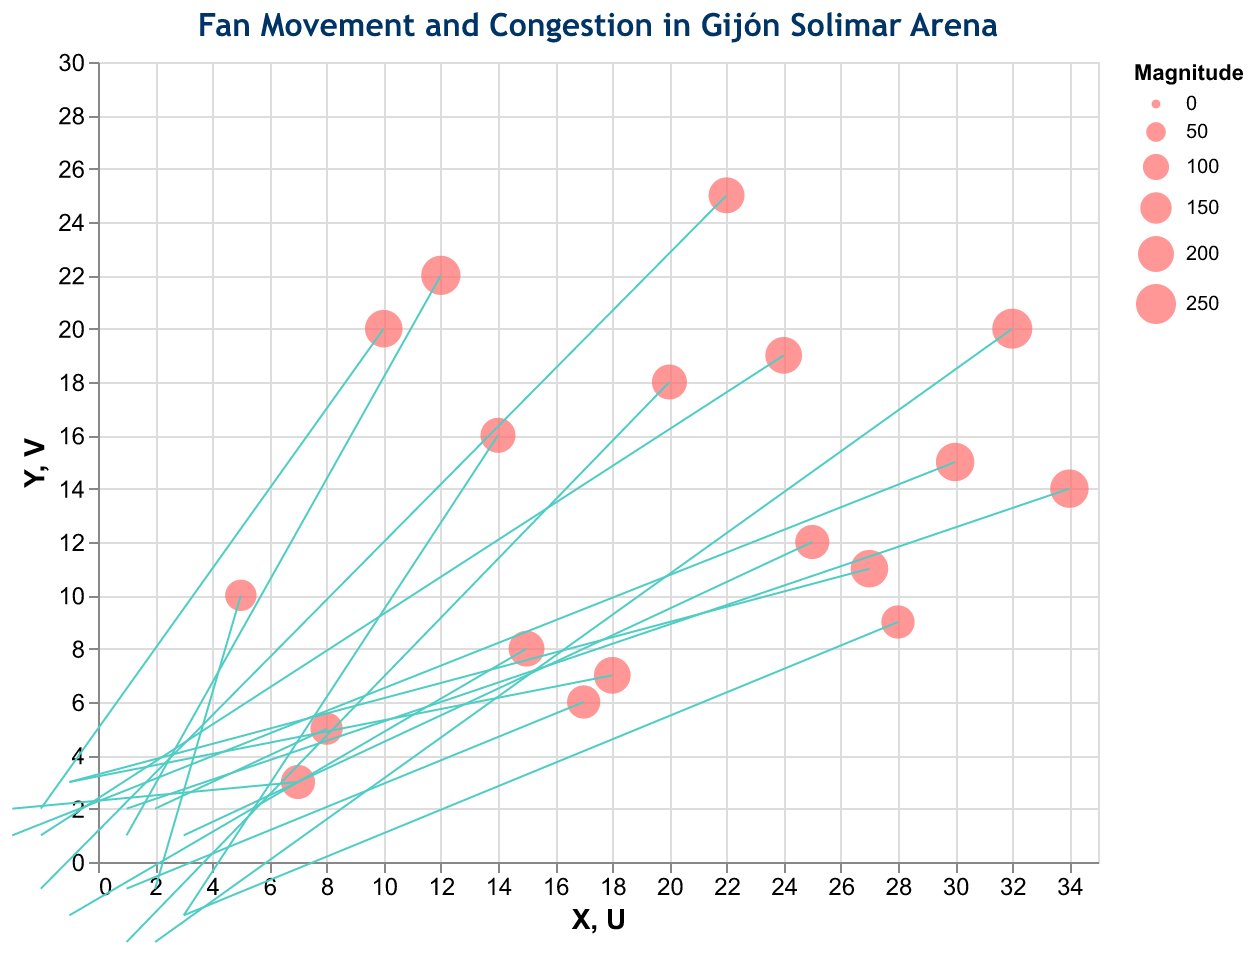how many data points are in the chart? Count the number of vectors (arrows) or dots represented in the plot. There are 18 unique (X, Y) positions, representing 18 data points.
Answer: 18 What is the title of the plot? The title is usually located at the top of the plot. For this plot, it reads "Fan Movement and Congestion in Gijón Solimar Arena."
Answer: Fan Movement and Congestion in Gijón Solimar Arena What are the units on the X-axis and Y-axis? Refer to the axes' labels and scale; they are quantitative and measured from 0 to the domain values 0-35 for X and 0-30 for Y.
Answer: Quantitative (0-35 for X, 0-30 for Y) Which data point has the highest congestion level? Identify the data point with the largest circle size since the size represents the Magnitude of congestion. The point at (32, 20) with a Magnitude of 250 has the highest congestion level.
Answer: (32, 20) What direction is the fan movement at (30, 15)? Look at the vector originating from (30, 15) - it moves leftward and slightly upward, as indicated by U = -3 and V = 1. This shows a movement towards (-3 in X, 1 in Y).
Answer: Leftward and slightly upward How many data points have a vertical movement component (V) greater than 2? Check the V values for each vector: Only the data points at (18, 7), (27, 11), (7, 3) and (8, 5) have V values greater than 2. There are 4 of them.
Answer: 4 Which regions in the arena have the most mixed congestion (areas with similar Magnus but opposite fan movement directions)? Compare pairs with similar Magnitudes but opposite directions in U and/or V: Points like (10, 20) and (15, 8) have nearly equal Magnitudes (220 and 200) but opposite movements in directions (-2,2) and (-1,-2).
Answer: Areas with similar congestion but different U and V vectors Which point shows no vertical movement? Look for data points where the vertical component V = 0. The point (12, 22) shows V = 1 and (17, 6) shows V = -1. The point (25, 12) has V = 1. So no data point shows exactly zero vertical movement
Answer: None 